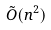<formula> <loc_0><loc_0><loc_500><loc_500>\tilde { O } ( n ^ { 2 } )</formula> 